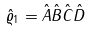Convert formula to latex. <formula><loc_0><loc_0><loc_500><loc_500>\hat { \varrho } _ { 1 } = \hat { A } \hat { B } \hat { C } \hat { D }</formula> 